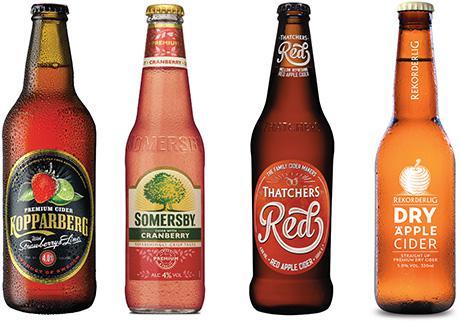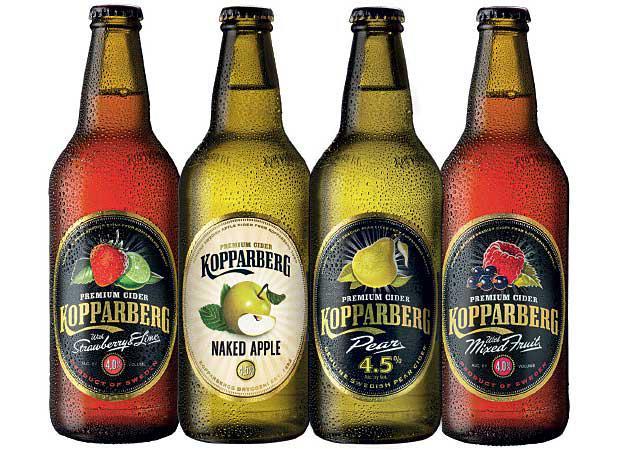The first image is the image on the left, the second image is the image on the right. Examine the images to the left and right. Is the description "The right and left images contain the same number of bottles." accurate? Answer yes or no. Yes. The first image is the image on the left, the second image is the image on the right. Assess this claim about the two images: "Each image contains the same number of capped bottles, all with different labels.". Correct or not? Answer yes or no. Yes. 